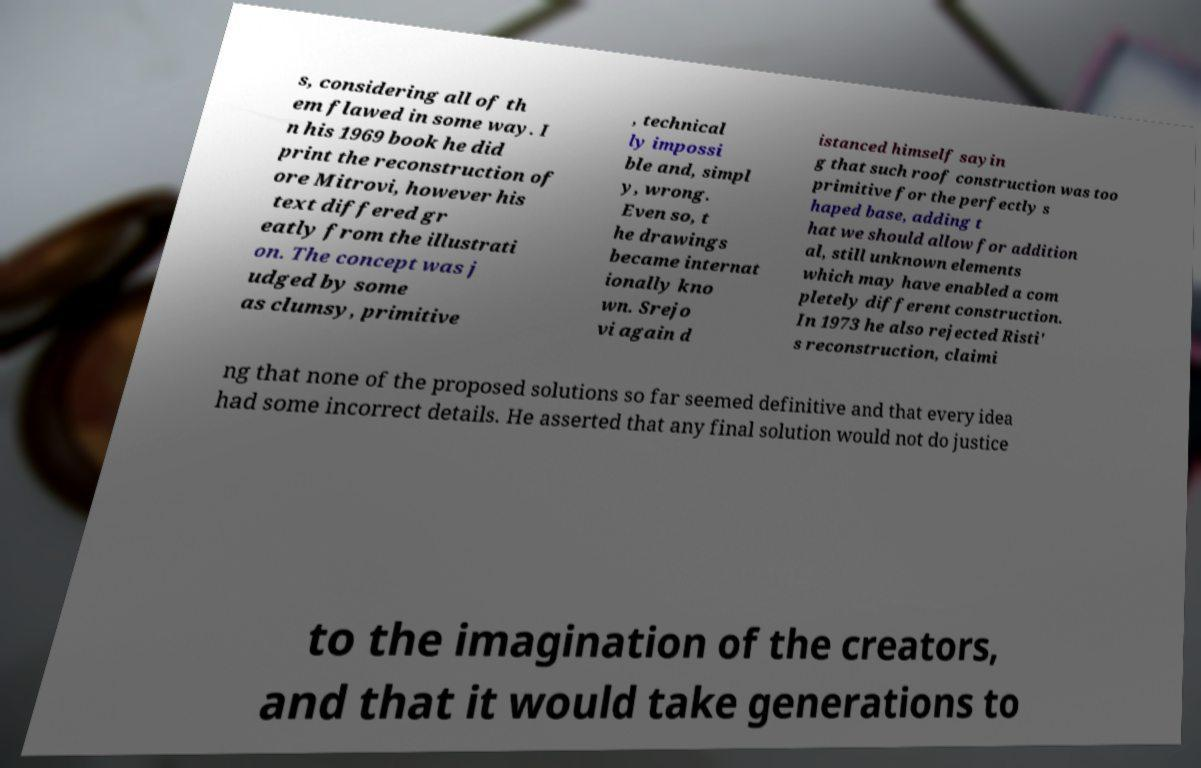Please identify and transcribe the text found in this image. s, considering all of th em flawed in some way. I n his 1969 book he did print the reconstruction of ore Mitrovi, however his text differed gr eatly from the illustrati on. The concept was j udged by some as clumsy, primitive , technical ly impossi ble and, simpl y, wrong. Even so, t he drawings became internat ionally kno wn. Srejo vi again d istanced himself sayin g that such roof construction was too primitive for the perfectly s haped base, adding t hat we should allow for addition al, still unknown elements which may have enabled a com pletely different construction. In 1973 he also rejected Risti' s reconstruction, claimi ng that none of the proposed solutions so far seemed definitive and that every idea had some incorrect details. He asserted that any final solution would not do justice to the imagination of the creators, and that it would take generations to 